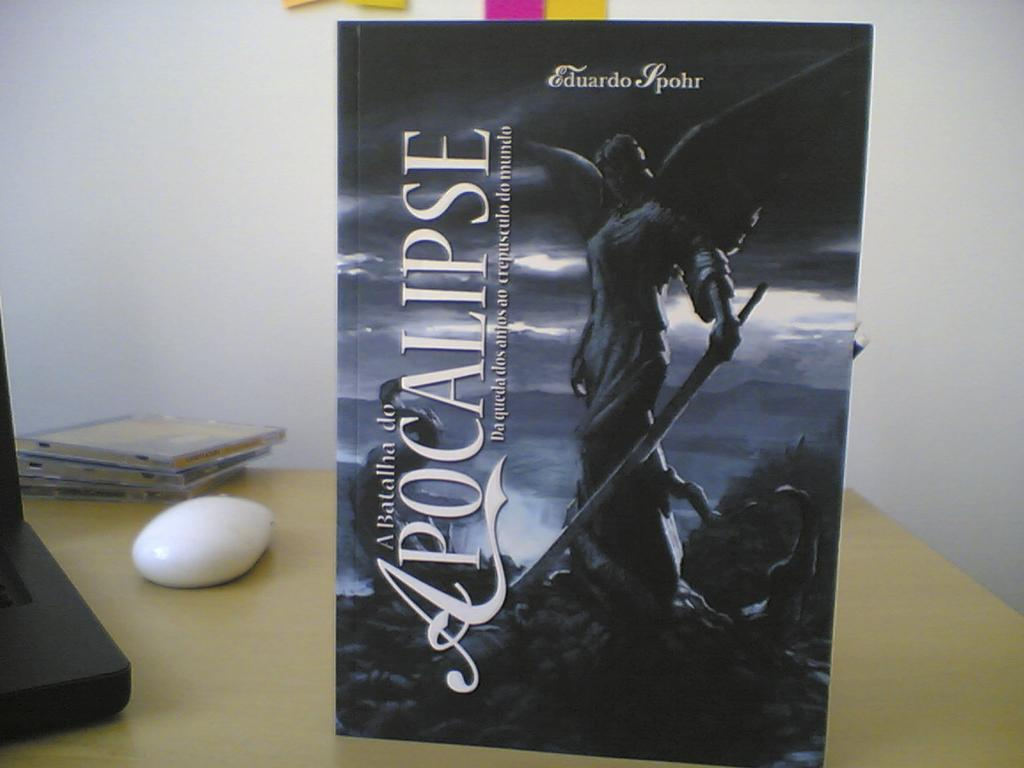<image>
Give a short and clear explanation of the subsequent image. the word apocalypse that is on a book 